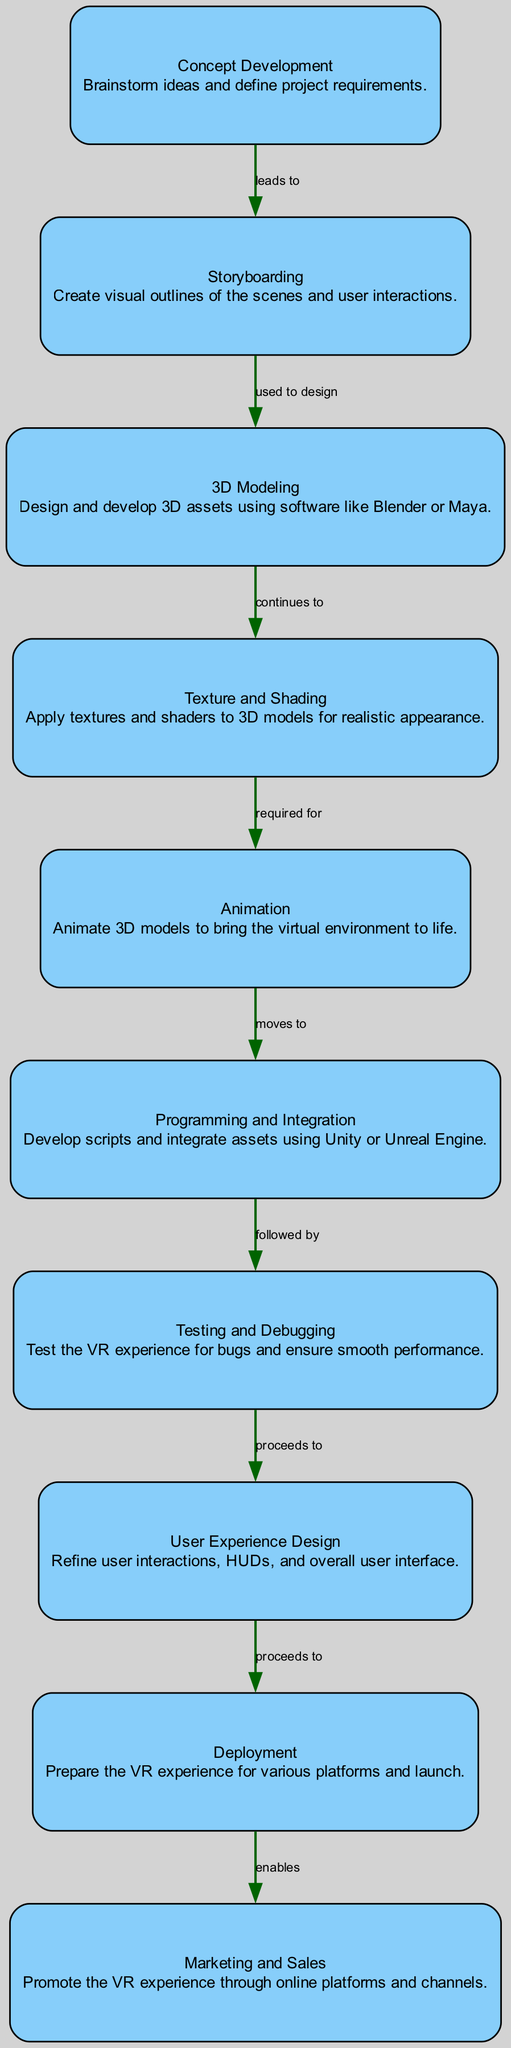What is the first step in the workflow? The first step in the workflow is "Concept Development." This is identified as the starting node labeled as number 1 in the diagram.
Answer: Concept Development How many nodes are present in the diagram? By counting the total number of distinct processes described in the diagram, we find that there are 10 nodes listed.
Answer: 10 What comes after Animation in the workflow? According to the edges in the diagram, "Animation" (node 5) moves to "Programming and Integration" (node 6). This means that the process following Animation is Programming and Integration.
Answer: Programming and Integration What is the relationship between Testing and Debugging and User Experience Design? The diagram shows that "Testing and Debugging" (node 7) proceeds to "User Experience Design" (node 8), indicating a direct flow or relationship from Testing and Debugging to User Experience Design.
Answer: proceeds to Which step focuses on promoting the VR experience? The last step in the workflow is "Marketing and Sales," which explicitly states the focus on promoting the VR experience through various channels.
Answer: Marketing and Sales What is necessary before Deployment? According to the workflow, before "Deployment" (node 9) occurs, the process "User Experience Design" (node 8) must be completed as the workflow proceeds from User Experience Design to Deployment.
Answer: User Experience Design How many edges connect the nodes in the workflow? Counting the relationships (edges) illustrated between the nodes in the diagram, we find there are 9 edges connecting these 10 nodes.
Answer: 9 Which software is mentioned for 3D Modeling? The description under "3D Modeling" indicates the use of software like Blender or Maya. This directly answers the question regarding the software mentioned in the workflow for this specific step.
Answer: Blender or Maya 